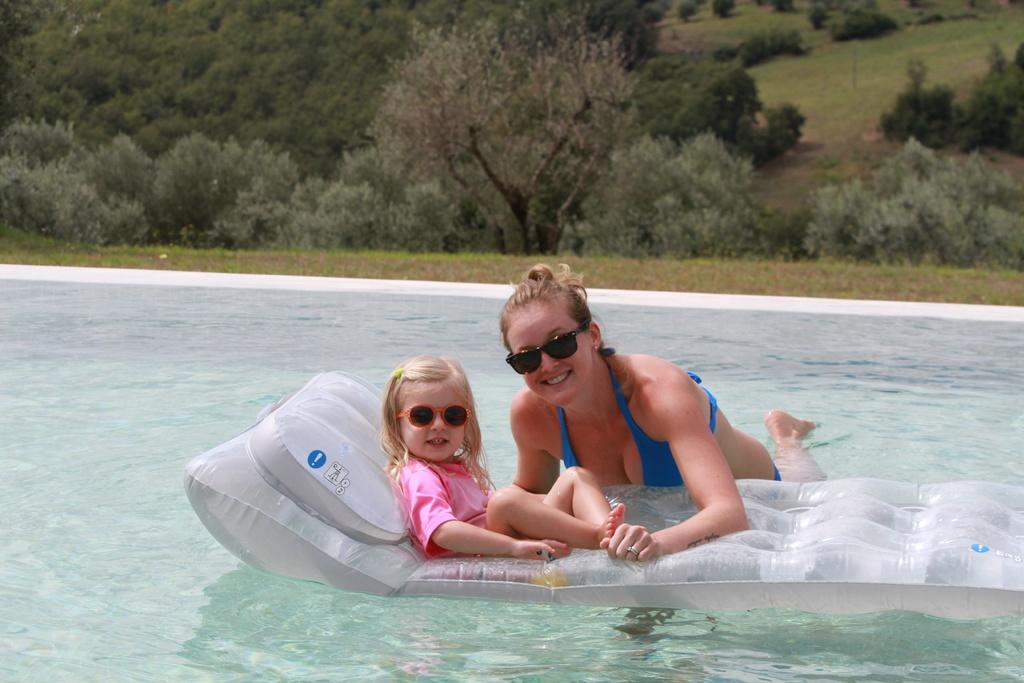What is the girl doing in the image? The girl is sitting on an inflatable in the image. What is the girl wearing on her face? The girl is wearing goggles in the image. What is the girl's facial expression? The girl is smiling in the image. Who else is in the water in the image? There is a woman in the water in the image. What is the woman wearing on her face? The woman is wearing goggles in the image. What is the woman's facial expression? The woman is smiling in the image. What can be seen in the background of the image? There are trees visible in the background of the image. What statement does the inflatable make about the girl's interest in politics? The image does not provide any information about the girl's interest in politics, nor does the inflatable make any statement about it. 